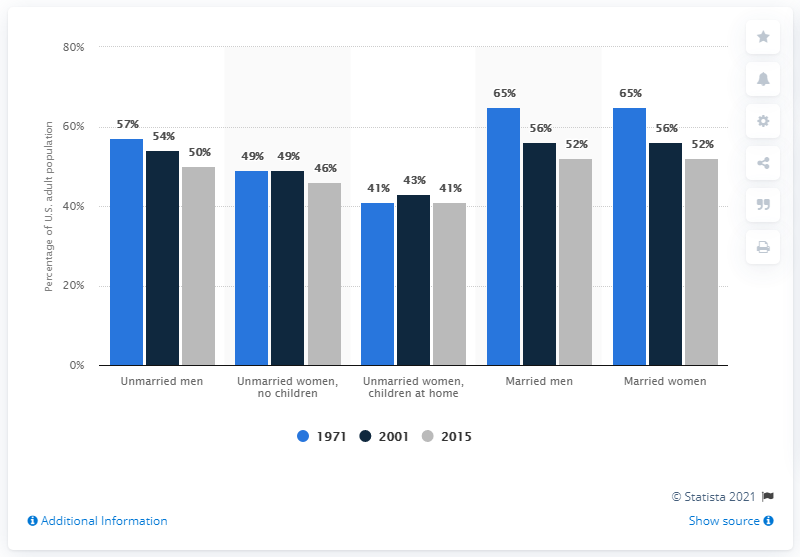List a handful of essential elements in this visual. The difference between the highest and lowest values recorded in the blue bar is 24. The highest recorded value in the grey bar is 52. 